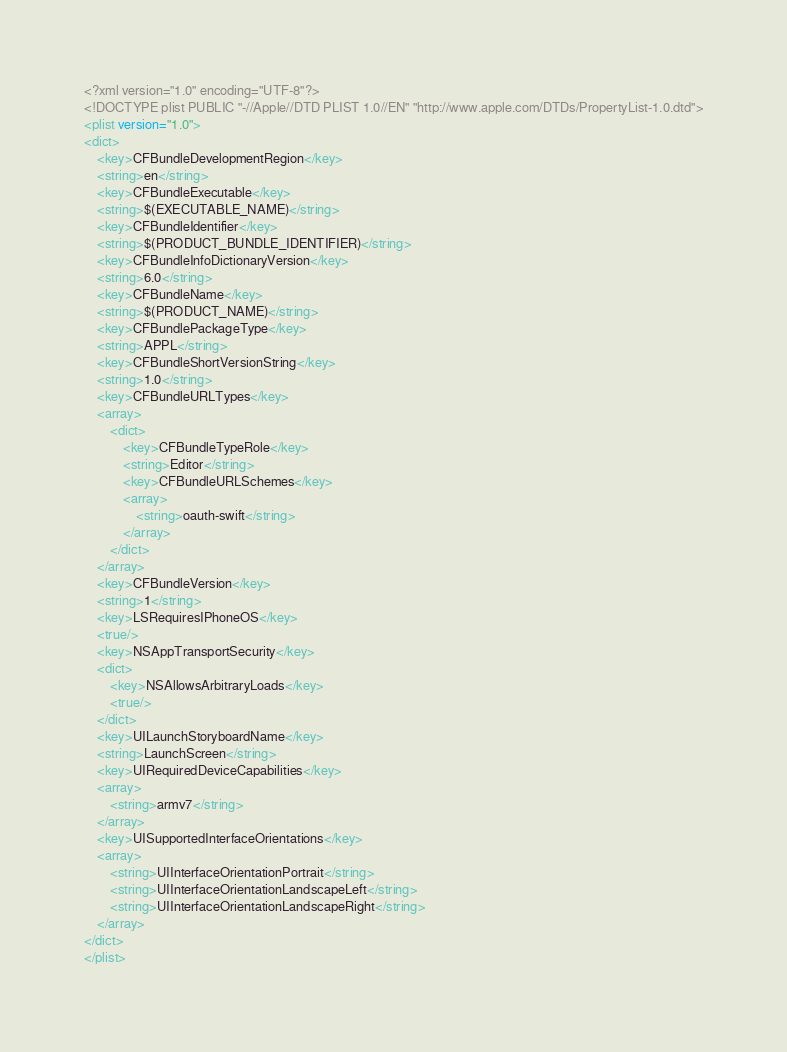Convert code to text. <code><loc_0><loc_0><loc_500><loc_500><_XML_><?xml version="1.0" encoding="UTF-8"?>
<!DOCTYPE plist PUBLIC "-//Apple//DTD PLIST 1.0//EN" "http://www.apple.com/DTDs/PropertyList-1.0.dtd">
<plist version="1.0">
<dict>
	<key>CFBundleDevelopmentRegion</key>
	<string>en</string>
	<key>CFBundleExecutable</key>
	<string>$(EXECUTABLE_NAME)</string>
	<key>CFBundleIdentifier</key>
	<string>$(PRODUCT_BUNDLE_IDENTIFIER)</string>
	<key>CFBundleInfoDictionaryVersion</key>
	<string>6.0</string>
	<key>CFBundleName</key>
	<string>$(PRODUCT_NAME)</string>
	<key>CFBundlePackageType</key>
	<string>APPL</string>
	<key>CFBundleShortVersionString</key>
	<string>1.0</string>
	<key>CFBundleURLTypes</key>
	<array>
		<dict>
			<key>CFBundleTypeRole</key>
			<string>Editor</string>
			<key>CFBundleURLSchemes</key>
			<array>
				<string>oauth-swift</string>
			</array>
		</dict>
	</array>
	<key>CFBundleVersion</key>
	<string>1</string>
	<key>LSRequiresIPhoneOS</key>
	<true/>
	<key>NSAppTransportSecurity</key>
	<dict>
		<key>NSAllowsArbitraryLoads</key>
		<true/>
	</dict>
	<key>UILaunchStoryboardName</key>
	<string>LaunchScreen</string>
	<key>UIRequiredDeviceCapabilities</key>
	<array>
		<string>armv7</string>
	</array>
	<key>UISupportedInterfaceOrientations</key>
	<array>
		<string>UIInterfaceOrientationPortrait</string>
		<string>UIInterfaceOrientationLandscapeLeft</string>
		<string>UIInterfaceOrientationLandscapeRight</string>
	</array>
</dict>
</plist>
</code> 